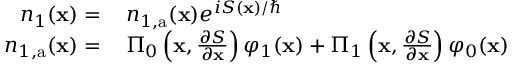<formula> <loc_0><loc_0><loc_500><loc_500>\begin{array} { r l } { n _ { 1 } ( x ) = \, } & n _ { 1 , a } ( x ) e ^ { i S ( x ) / } } \\ { n _ { 1 , a } ( x ) = \, } & \Pi _ { 0 } \left ( x , \frac { \partial S } { \partial x } \right ) \varphi _ { 1 } ( x ) + \Pi _ { 1 } \left ( x , \frac { \partial S } { \partial x } \right ) \varphi _ { 0 } ( x ) } \end{array}</formula> 